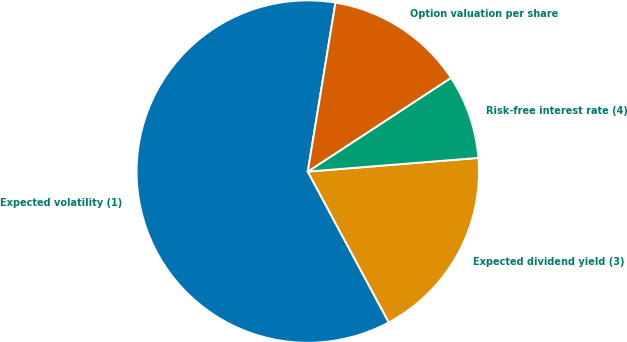<chart> <loc_0><loc_0><loc_500><loc_500><pie_chart><fcel>Expected volatility (1)<fcel>Expected dividend yield (3)<fcel>Risk-free interest rate (4)<fcel>Option valuation per share<nl><fcel>60.43%<fcel>18.43%<fcel>7.95%<fcel>13.19%<nl></chart> 